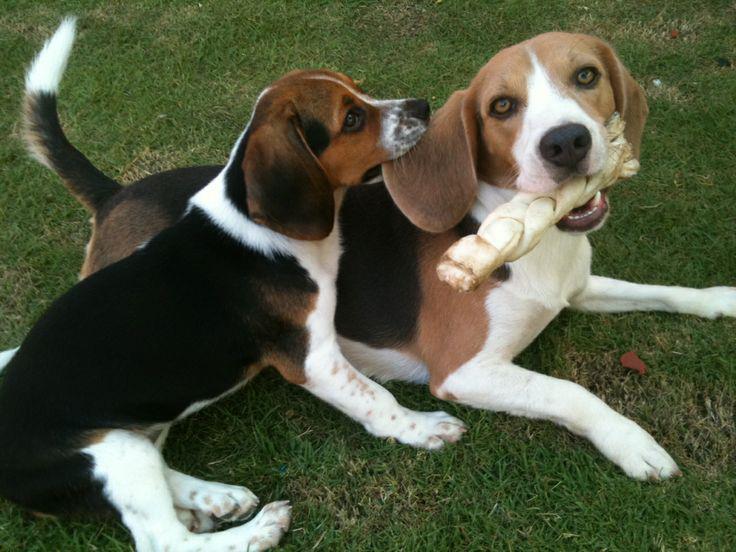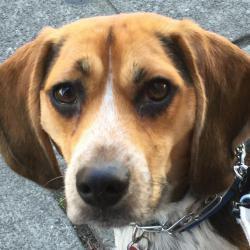The first image is the image on the left, the second image is the image on the right. Analyze the images presented: Is the assertion "The right image contains exactly two dogs." valid? Answer yes or no. No. The first image is the image on the left, the second image is the image on the right. Analyze the images presented: Is the assertion "One image contains twice as many beagles as the other, and the combined images total three dogs." valid? Answer yes or no. Yes. 